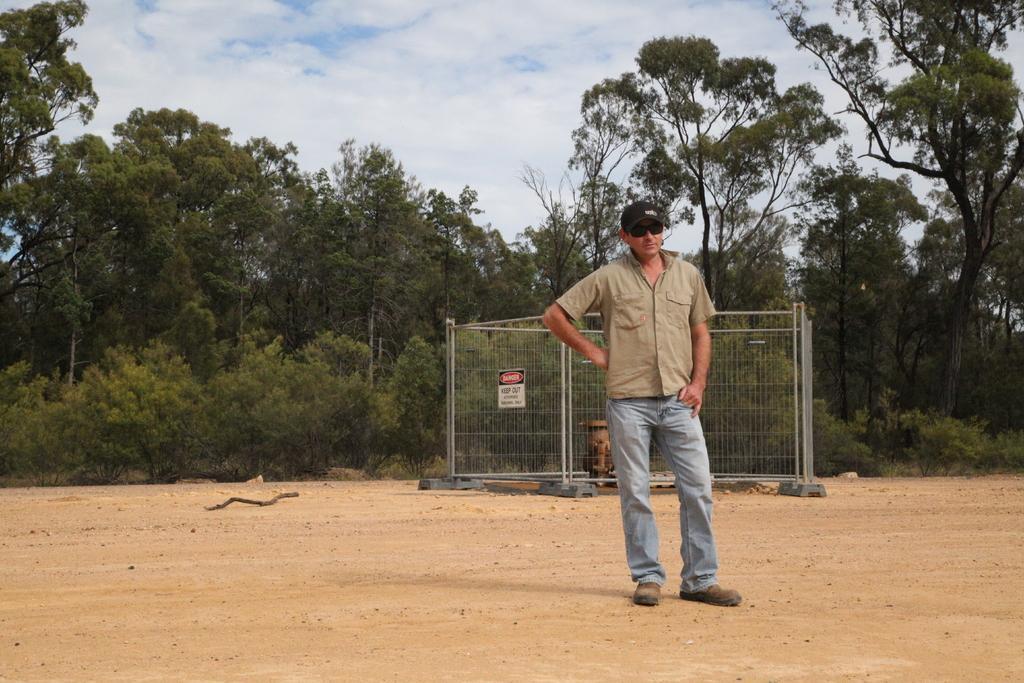How would you summarize this image in a sentence or two? In this image we can see a person, fence and other objects. In the background of the image there are trees and the sky. At the bottom of the image there is the ground. 